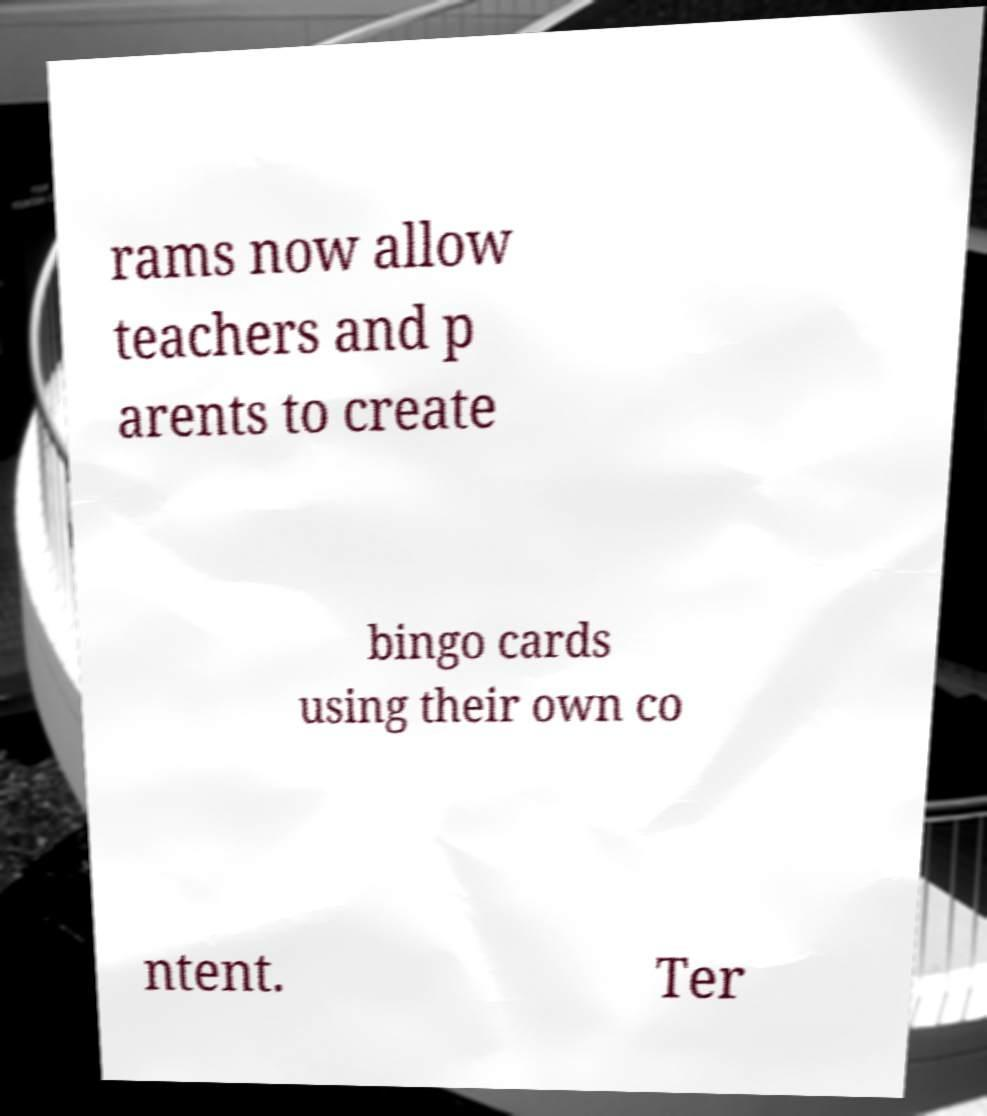Can you accurately transcribe the text from the provided image for me? rams now allow teachers and p arents to create bingo cards using their own co ntent. Ter 